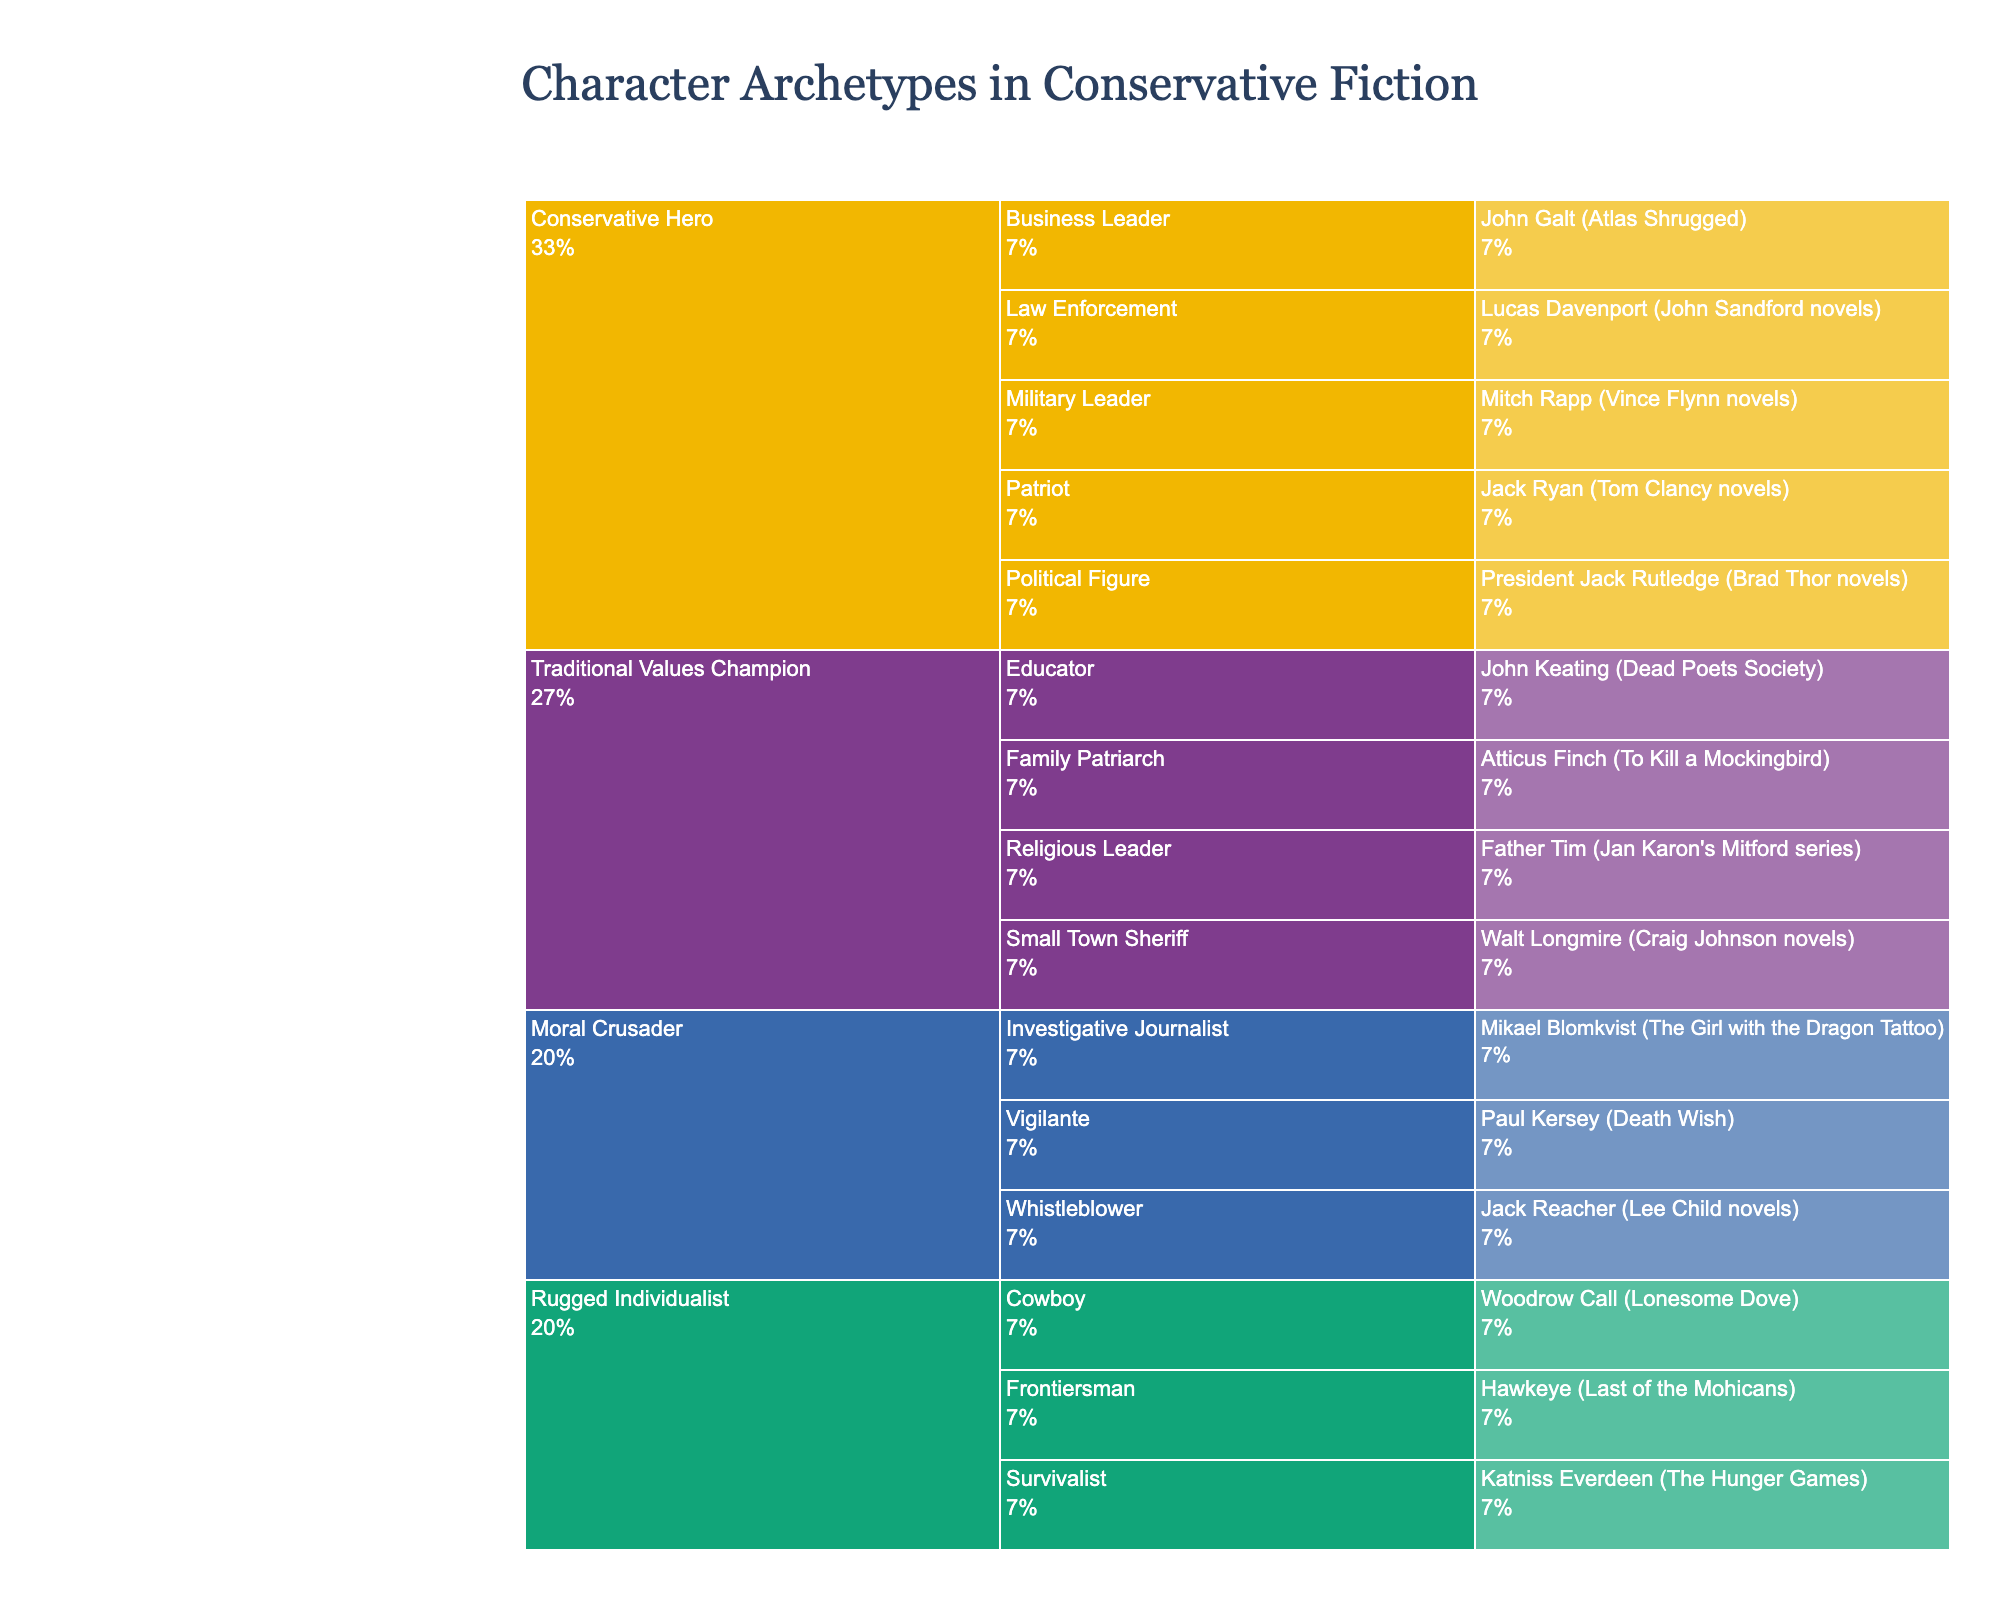What's the title of the icicle chart? The title of a chart is usually displayed prominently at the top of the figure. In this case, it's mentioned in the code that the title is 'Character Archetypes in Conservative Fiction'.
Answer: Character Archetypes in Conservative Fiction How many 'Conservative Hero' protagonist roles are depicted in the chart? You need to look at the section labeled 'Conservative Hero' and count the subcategories under it. The listed roles are Patriot, Military Leader, Law Enforcement, Political Figure, and Business Leader.
Answer: 5 Which protagonist role under 'Traditional Values Champion' also appears in a well-known novel about a small town lawyer? Identifying the 'Family Patriarch' as one of the roles, and recalling "To Kill a Mockingbird" features Atticus Finch, a famous small-town lawyer, leads to the correct role.
Answer: Family Patriarch Compare the number of protagonist roles for 'Conservative Hero' versus 'Traditional Values Champion'. Which one has more? Counting the roles under each category shows Conservative Hero with 5 roles and Traditional Values Champion with 4 roles. Thus, Conservative Hero has more roles.
Answer: Conservative Hero What percentage of the total does the 'Rugged Individualist' category represent? Each section of the icicle chart can display the percentage of the total entries it represents. By examining the chart, 'Rugged Individualist' shows its contribution to the overall figure.
Answer: 20% Which role under 'Moral Crusader' is specifically linked with an investigative occupation? Looking at the roles under 'Moral Crusader', the role of Investigative Journalist links to the occupation of investigating.
Answer: Investigative Journalist How many protagonist roles in total are depicted across all categories? Summing up the roles from each category: 5 (Conservative Hero) + 4 (Traditional Values Champion) + 3 (Rugged Individualist) + 3 (Moral Crusader). This totals 15 roles.
Answer: 15 Which protagonist role has the same number of specific examples as 'Vigilante' under 'Moral Crusader'? Both 'Vigilante' and other roles like 'Whistleblower' each have 1 specific example according to the data in the chart.
Answer: Whistleblower What's the respective percentage for 'Law Enforcement' under 'Conservative Hero'? The displayed percentage in the icicle chart next to 'Law Enforcement' under 'Conservative Hero' can be directly referred to.
Answer: 6.67% What is the combined percentage of 'Vigilante' and 'Investigative Journalist' in 'Moral Crusader'? Adding the percentages shown in the icicle chart for 'Vigilante' (6.67% or similar) and 'Investigative Journalist' (6.67% or similar) gives the combined total.
Answer: 13.34% 